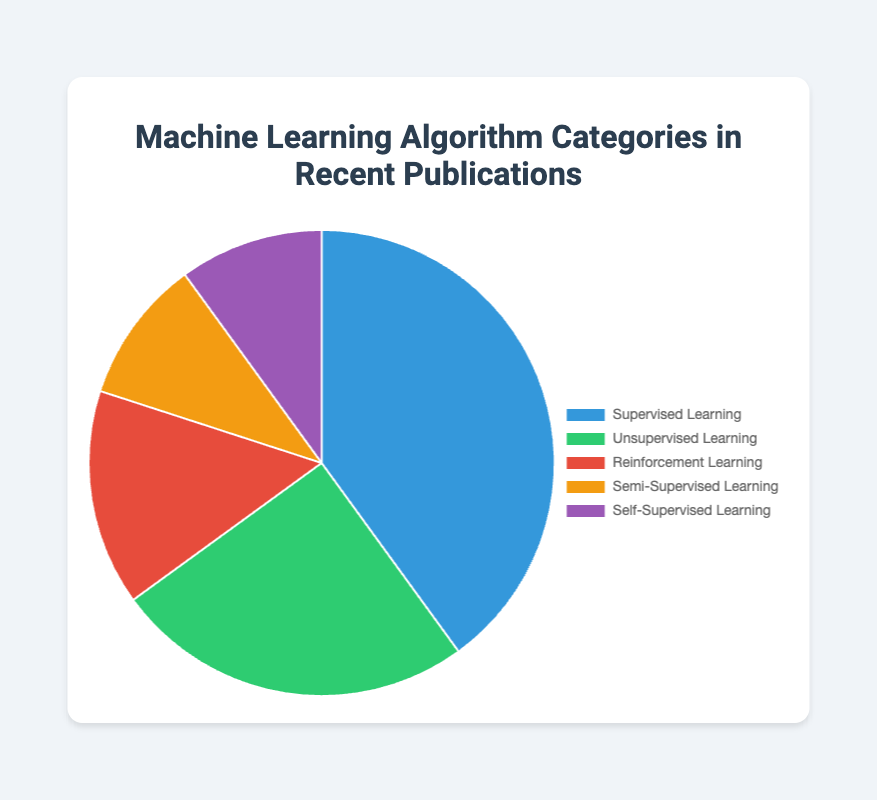What is the most discussed machine learning algorithm category in recent publications? The category with the highest percentage value in the pie chart represents the most discussed category. "Supervised Learning" has the highest percentage of 40%.
Answer: Supervised Learning What percentage of the publications discuss reinforcement learning? The pie chart shows a segment labeled "Reinforcement Learning" with a corresponding percentage. This value is 15% as shown in the pie chart.
Answer: 15% Which type of learning algorithms combined make up 20% of recent publications? Adding the percentages for "Semi-Supervised Learning" and "Self-Supervised Learning" results in 10% + 10%. Therefore, these two types combined account for 20% of recent publications.
Answer: Semi-Supervised Learning and Self-Supervised Learning What is the difference in percentage between publications discussing supervised learning and unsupervised learning? Subtract the percentage of "Unsupervised Learning" (25%) from "Supervised Learning" (40%). 40% - 25% = 15%.
Answer: 15% Which categories together constitute the majority (over 50%) of the publications? Adding the percentages of the most discussed categories until the sum exceeds 50%. "Supervised Learning" (40%) + "Unsupervised Learning" (25%) = 65%. These categories together exceed 50%.
Answer: Supervised Learning and Unsupervised Learning Which category is represented by the green segment in the pie chart? From the visual attributes, the green segment represents "Unsupervised Learning" as shown in the chart's color legend.
Answer: Unsupervised Learning How many types of machine learning algorithms are discussed in recent publications according to the chart? Count the number of distinct categories labeled in the pie chart. There are five: "Supervised Learning," "Unsupervised Learning," "Reinforcement Learning," "Semi-Supervised Learning," and "Self-Supervised Learning."
Answer: 5 By what percentage does the segment for reinforcement learning exceed the segments for semi-supervised and self-supervised learning individually? The percentage for "Reinforcement Learning" is 15%. Subtract the individual percentages of "Semi-Supervised Learning" and "Self-Supervised Learning" from 15%. 15% - 10% = 5% for each.
Answer: 5% What percentage of the publications discuss types of learning other than supervised or unsupervised learning? Add the percentages for all categories except "Supervised Learning" and "Unsupervised Learning". 15% (Reinforcement Learning) + 10% (Semi-Supervised Learning) + 10% (Self-Supervised Learning) = 35%.
Answer: 35% Which categories are equally represented in the publications according to the pie chart? The pie chart shows segments for "Semi-Supervised Learning" and "Self-Supervised Learning" both labeled with 10%.
Answer: Semi-Supervised Learning and Self-Supervised Learning 